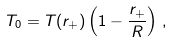<formula> <loc_0><loc_0><loc_500><loc_500>T _ { 0 } = T ( r _ { + } ) \left ( 1 - \frac { r _ { + } } { R } \right ) \, ,</formula> 